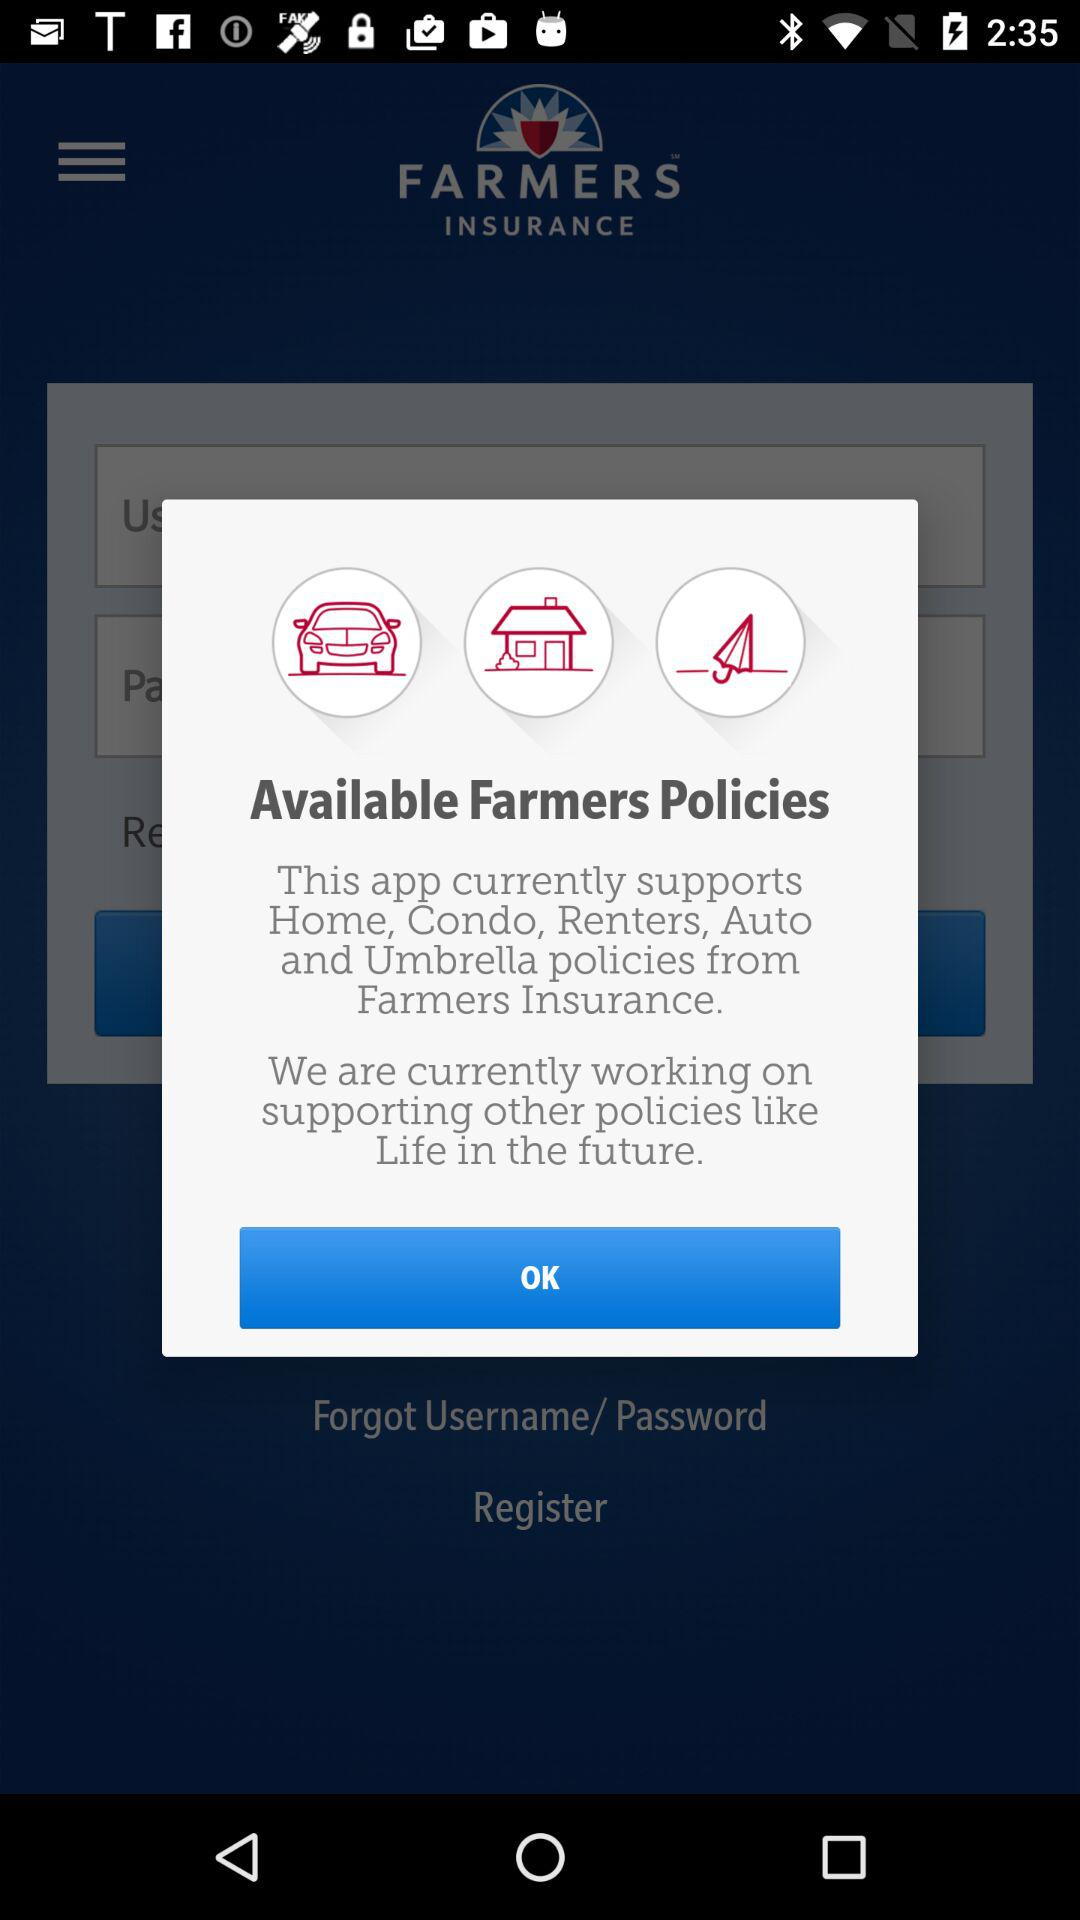What are the things that are covered in a farmers insurance policy? The things are "Home", "Condo","Renters", "Auto", and "Umbrella". 